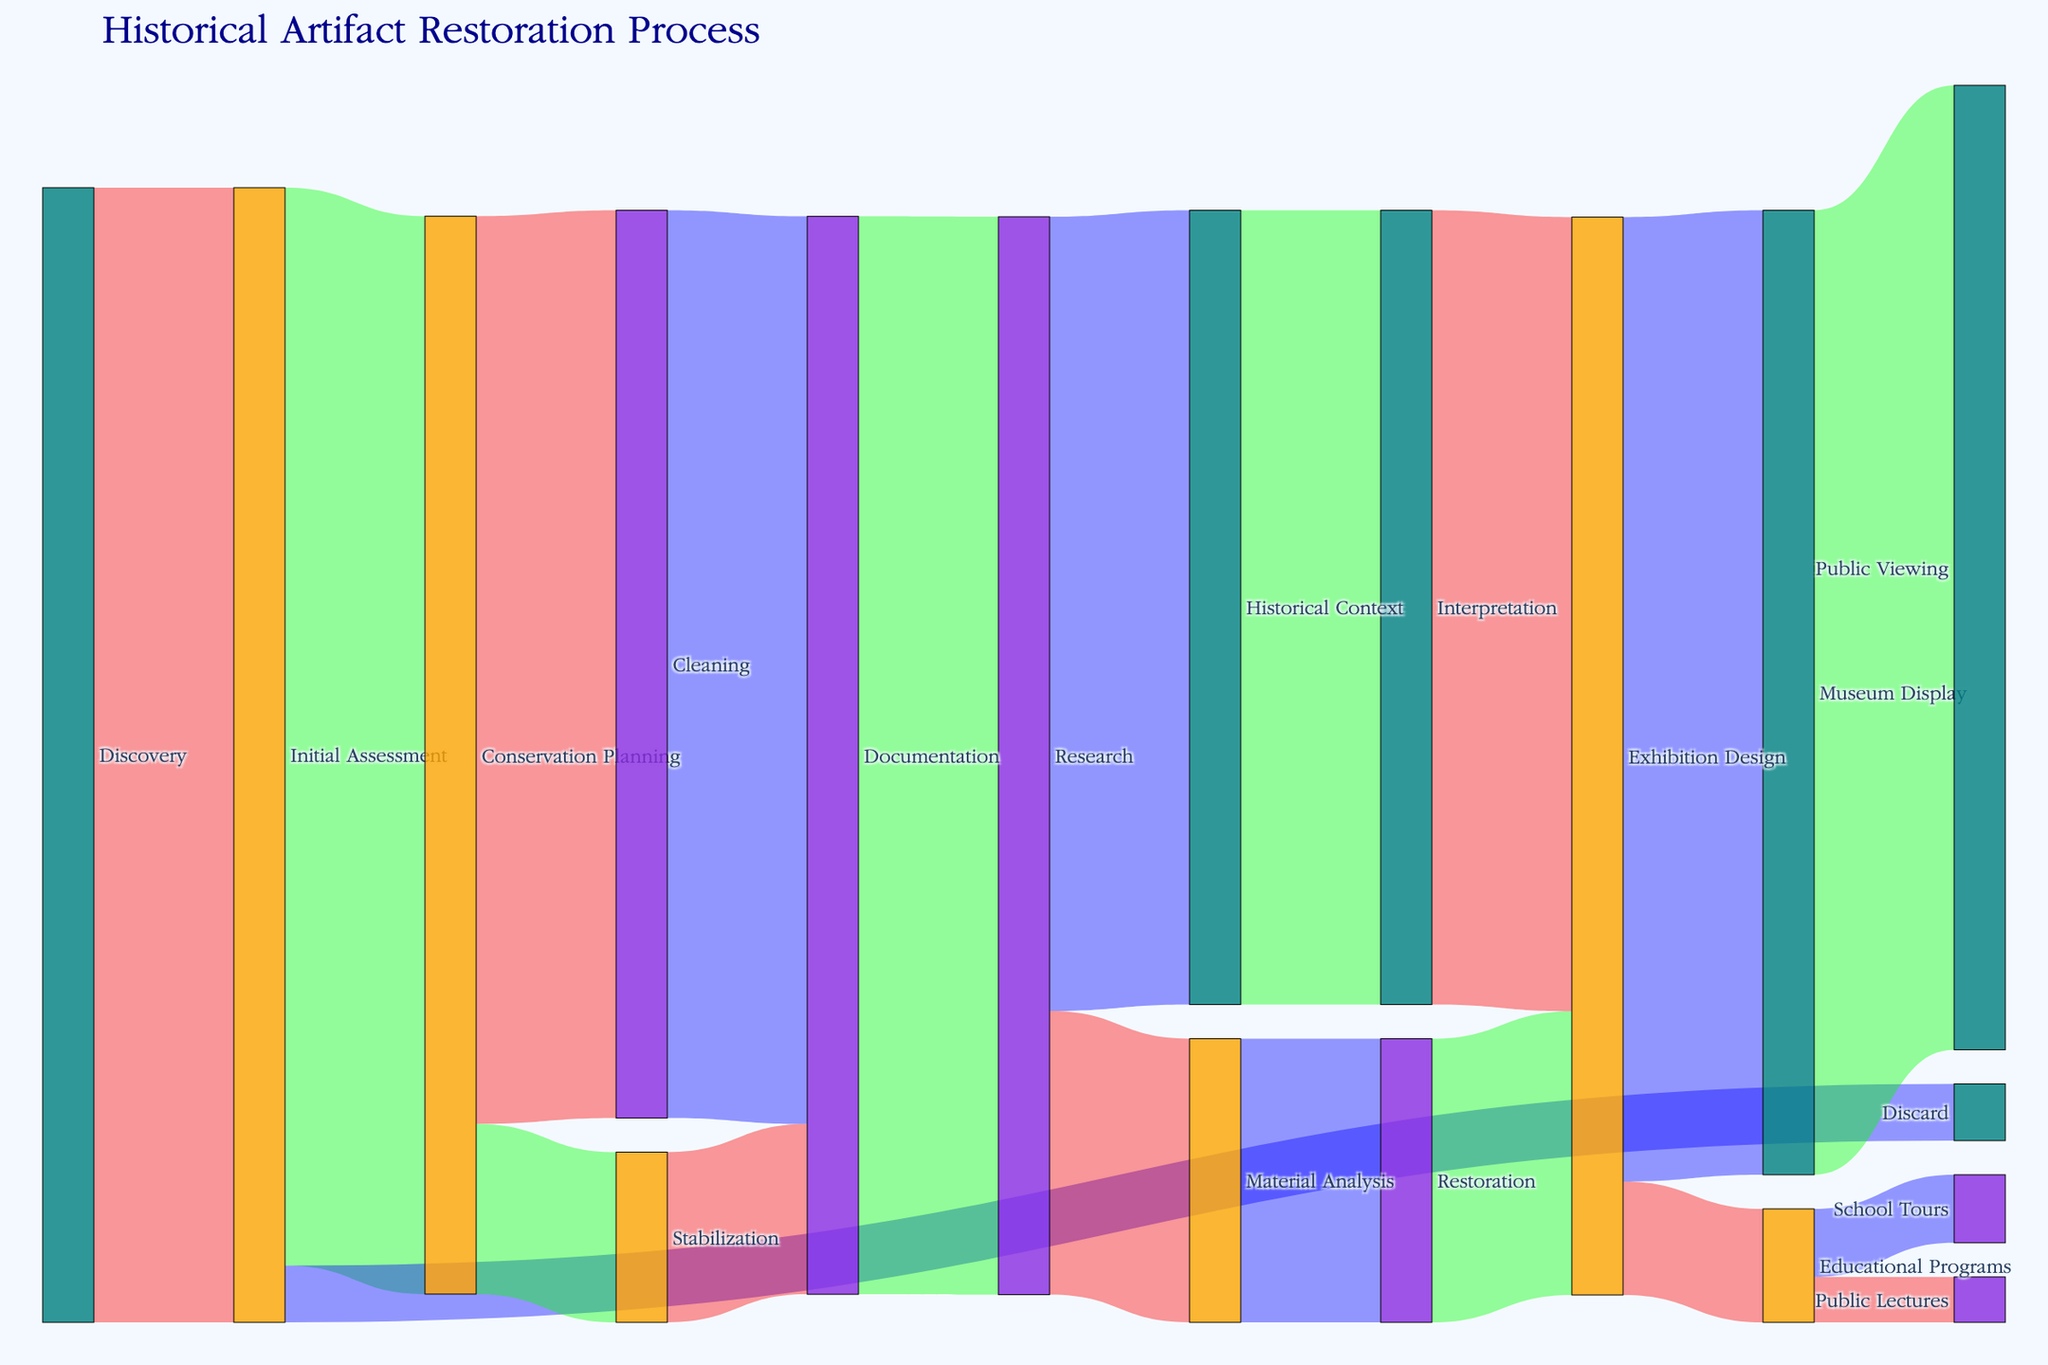What is the title of the diagram? The title of the diagram is located at the top. It reads "Historical Artifact Restoration Process."
Answer: Historical Artifact Restoration Process From the 'Discovery' stage, how many artifacts move to 'Initial Assessment'? The flow value between 'Discovery' and 'Initial Assessment' indicates the number of artifacts, which is 100.
Answer: 100 How many artifacts are discarded at 'Initial Assessment'? The flow line from 'Initial Assessment' to 'Discard' shows the number of artifacts, which is 5.
Answer: 5 What is the combined number of artifacts that proceed to 'Exhibition Design'? To find the total number of artifacts leading to 'Exhibition Design', sum the artifacts from 'Interpretation' (70) and 'Restoration' (25). Thus, 70 + 25 equals 95.
Answer: 95 Which stage has the highest number of artifacts flowing into 'Museum Display'? The flow value into 'Museum Display' is 85, which only comes from 'Exhibition Design'. So, 'Exhibition Design' is the correct stage.
Answer: Exhibition Design Compare the number of artifacts that end up in 'School Tours' versus 'Public Lectures'. Which one receives more artifacts? 'School Tours' gets 6 artifacts, while 'Public Lectures' gets 4. Comparing these, 'School Tours' receives more artifacts.
Answer: School Tours Of the artifacts undergoing 'Research', how many proceed to 'Material Analysis'? The flow value from 'Research' to 'Material Analysis' is 25.
Answer: 25 Calculate the number of artifacts that transition through 'Documentation'. To find the total in 'Documentation', add artifacts from 'Cleaning' (80) and 'Stabilization' (15). Thus, 80 + 15 equals 95.
Answer: 95 Which stage follows 'Historical Context'? 'Historical Context' flows into 'Interpretation', as indicated by the diagram.
Answer: Interpretation 